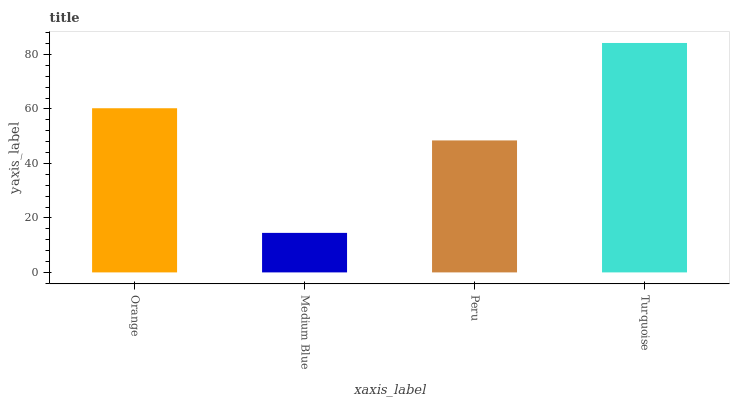Is Medium Blue the minimum?
Answer yes or no. Yes. Is Turquoise the maximum?
Answer yes or no. Yes. Is Peru the minimum?
Answer yes or no. No. Is Peru the maximum?
Answer yes or no. No. Is Peru greater than Medium Blue?
Answer yes or no. Yes. Is Medium Blue less than Peru?
Answer yes or no. Yes. Is Medium Blue greater than Peru?
Answer yes or no. No. Is Peru less than Medium Blue?
Answer yes or no. No. Is Orange the high median?
Answer yes or no. Yes. Is Peru the low median?
Answer yes or no. Yes. Is Turquoise the high median?
Answer yes or no. No. Is Turquoise the low median?
Answer yes or no. No. 